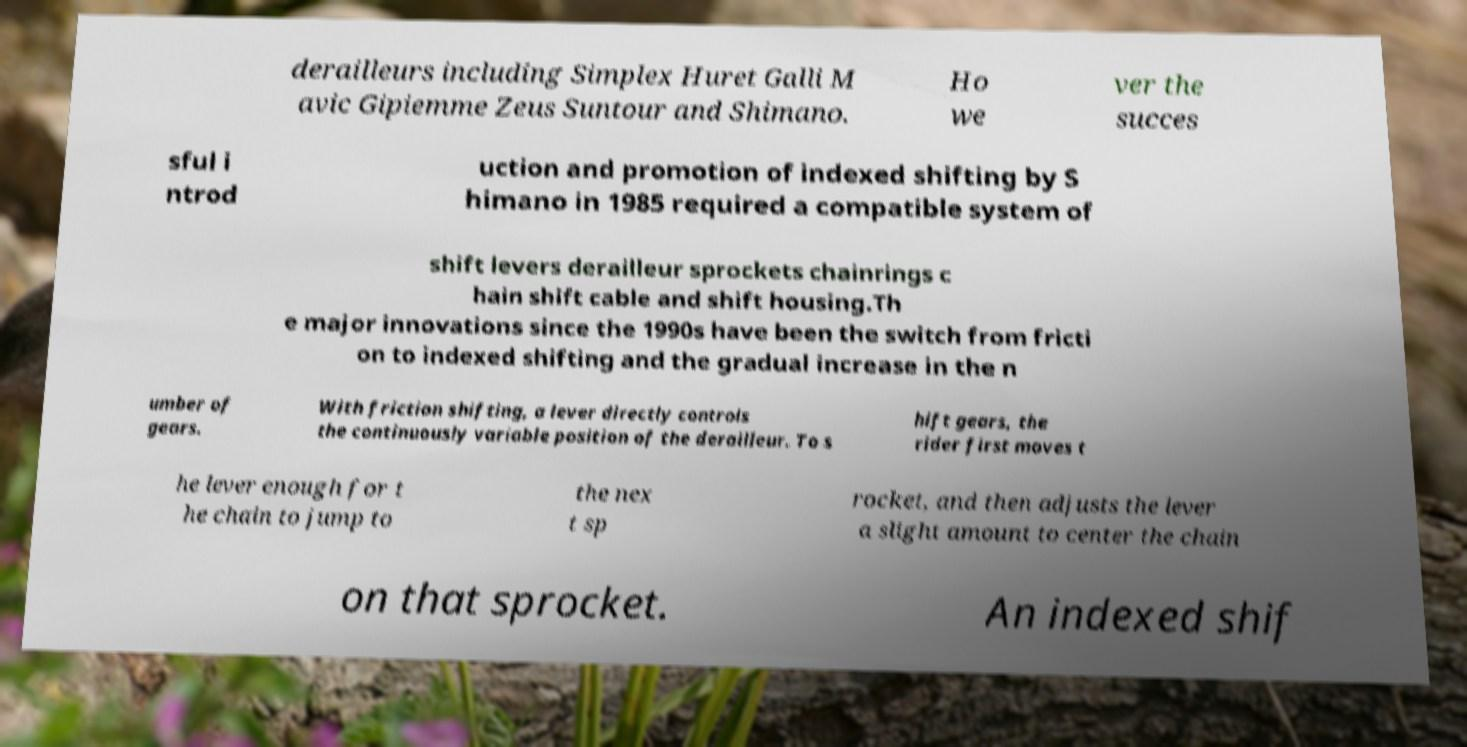Can you accurately transcribe the text from the provided image for me? derailleurs including Simplex Huret Galli M avic Gipiemme Zeus Suntour and Shimano. Ho we ver the succes sful i ntrod uction and promotion of indexed shifting by S himano in 1985 required a compatible system of shift levers derailleur sprockets chainrings c hain shift cable and shift housing.Th e major innovations since the 1990s have been the switch from fricti on to indexed shifting and the gradual increase in the n umber of gears. With friction shifting, a lever directly controls the continuously variable position of the derailleur. To s hift gears, the rider first moves t he lever enough for t he chain to jump to the nex t sp rocket, and then adjusts the lever a slight amount to center the chain on that sprocket. An indexed shif 